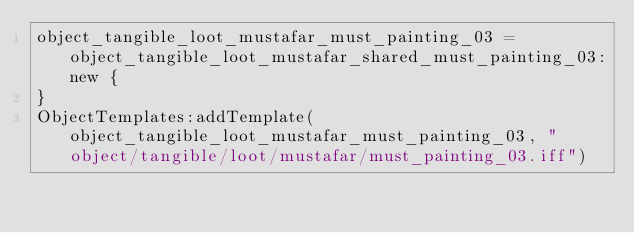Convert code to text. <code><loc_0><loc_0><loc_500><loc_500><_Lua_>object_tangible_loot_mustafar_must_painting_03 = object_tangible_loot_mustafar_shared_must_painting_03:new {
}
ObjectTemplates:addTemplate(object_tangible_loot_mustafar_must_painting_03, "object/tangible/loot/mustafar/must_painting_03.iff")
</code> 